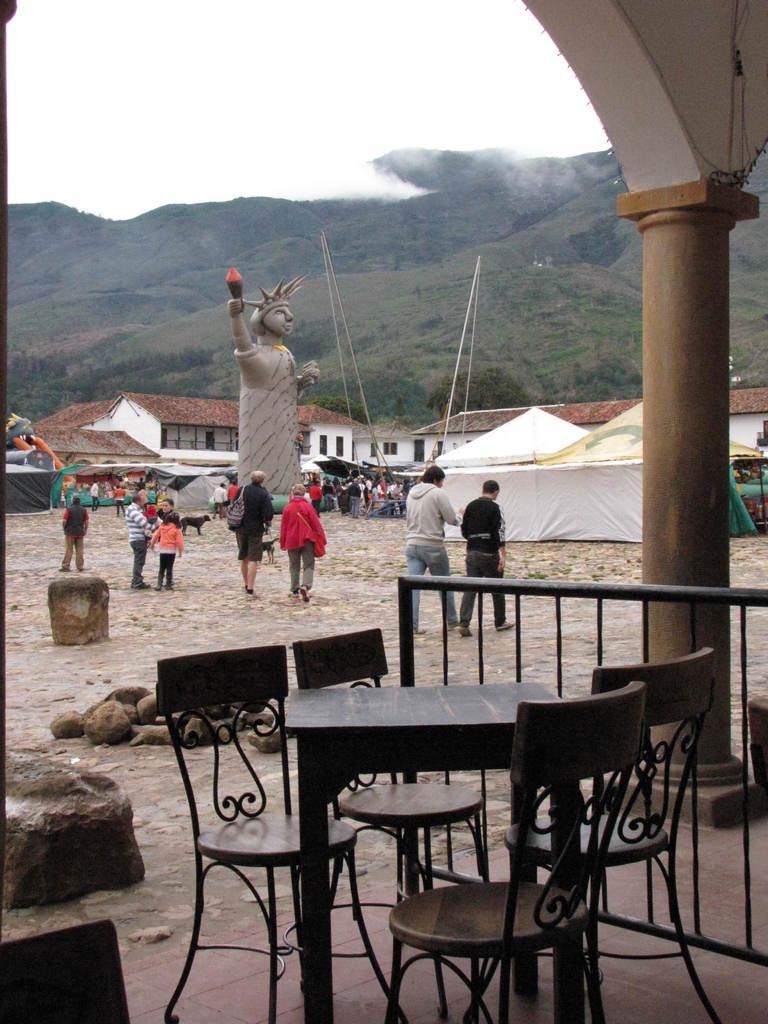How would you summarize this image in a sentence or two? At the bottom there is a table and few chairs. On the right side there is a railing and a pillar. On the left side there are few stones on the ground. In the background there are few people walking on the ground and there is a statue of a person. In the background there are many trees and houses and also there is a tent. At the top of the image I can see the sky. 